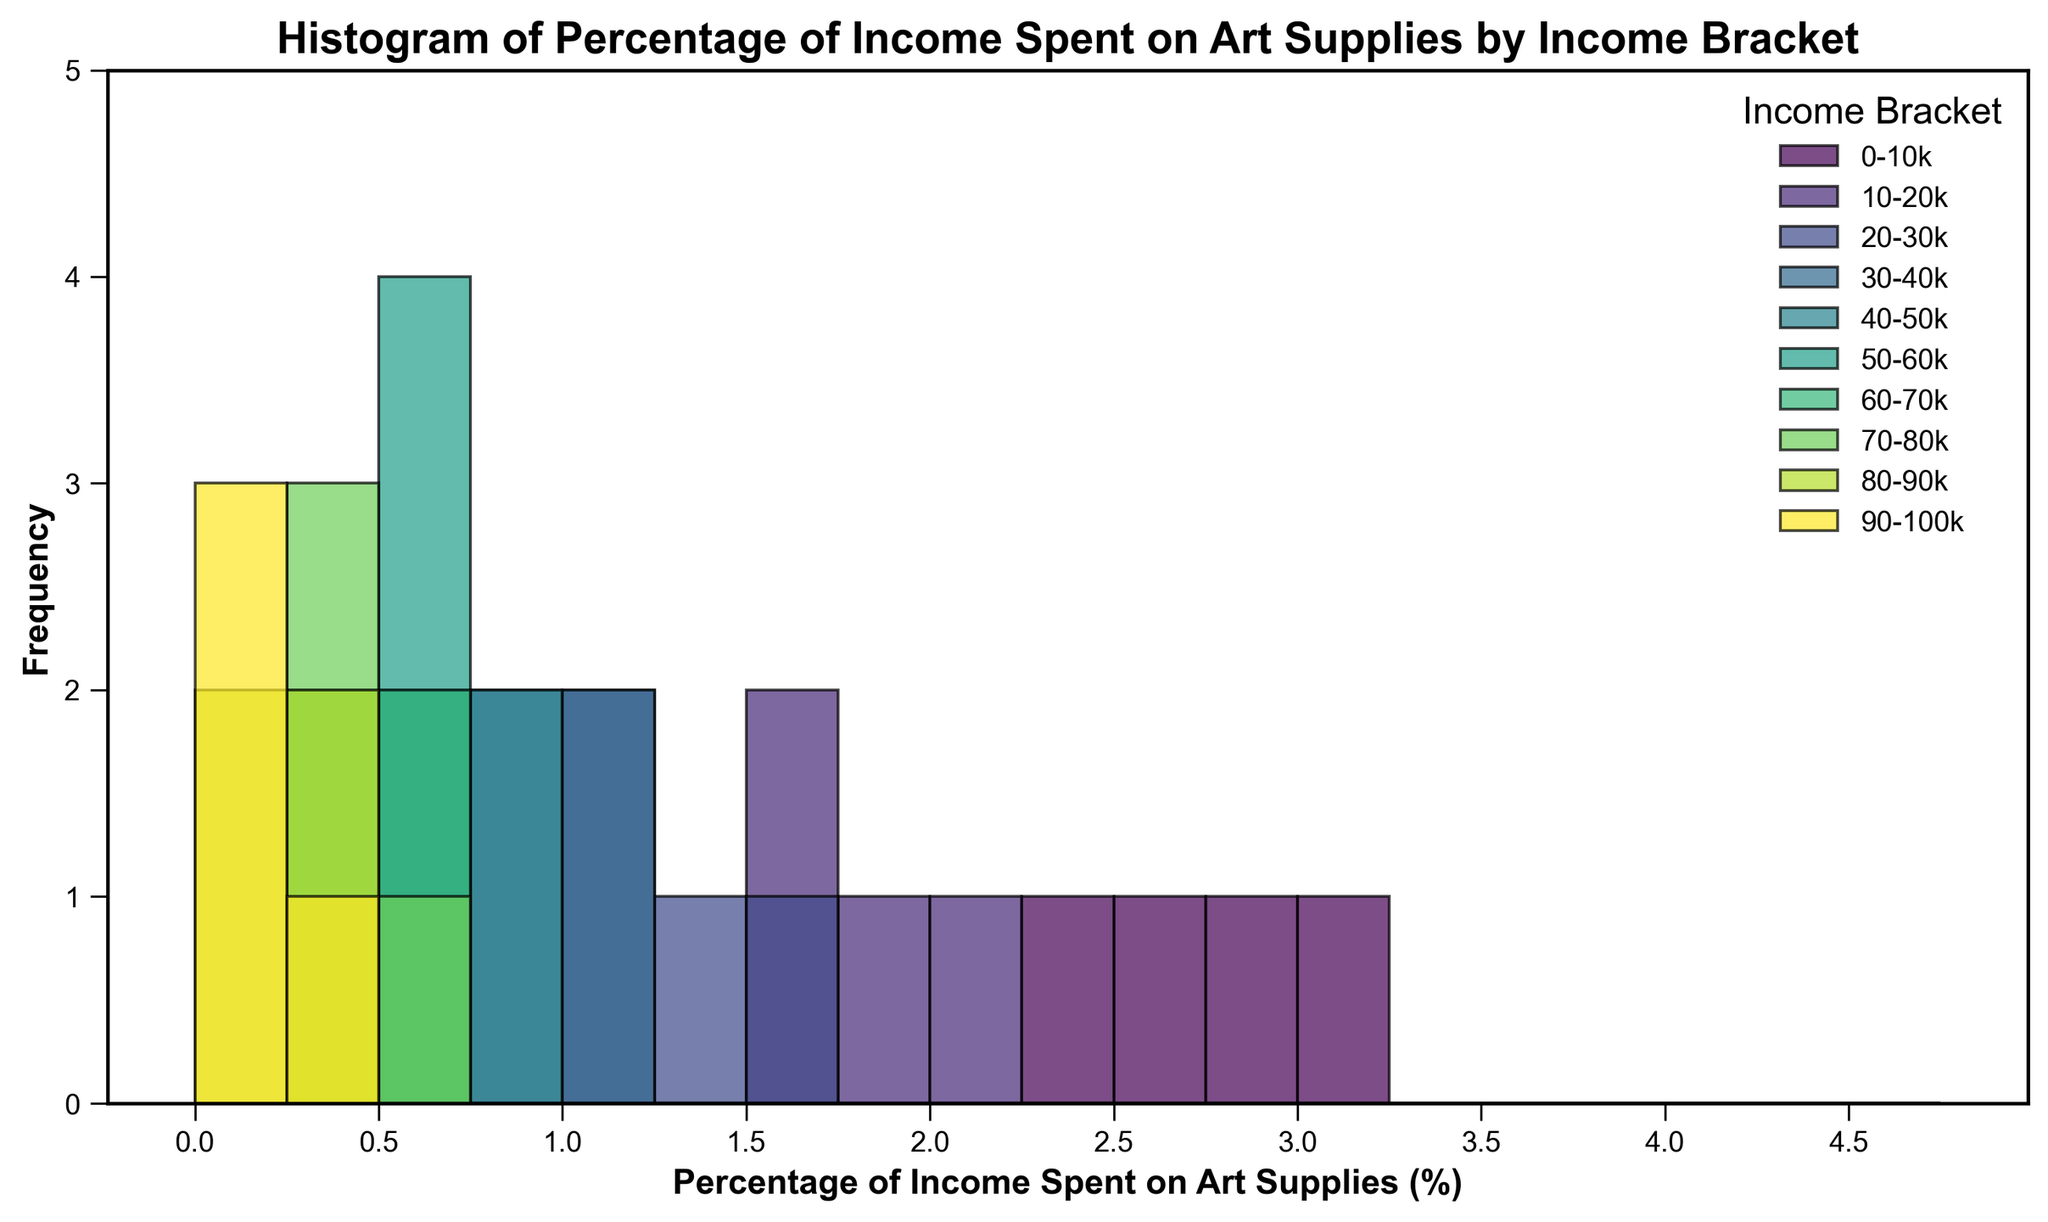Which income bracket has the highest percentage of income spent on art supplies? By looking at the tallest bars in the histogram, we can determine the 0-10k income bracket spends the highest percentage on art supplies.
Answer: 0-10k Which income bracket has the lowest percentage of income spent on art supplies? The shortest bars on the histogram indicate the amount spent; 90-100k has the lowest percentages.
Answer: 90-100k Is the percentage of income spent on art supplies higher for lower income brackets compared to higher income brackets? By examining the histogram, we can see that the lower income brackets have higher bars at higher percentages, showing they spend a larger portion of their income on art supplies.
Answer: Yes What is the most common percentage range of income spent on art supplies for the 10-20k income bracket? The most frequent bar height for the 10-20k group is between 1.5% and 2.0%.
Answer: 1.5% - 2.0% How does the frequency of spending compare between the 30-40k and 50-60k income brackets? Comparing the histograms for these two groups shows that the 30-40k bracket has taller bars compared to the 50-60k income bracket for percentages above 0.5%, suggesting higher frequency.
Answer: 30-40k bracket spends more frequently Do any income brackets have overlapping spending percentages? By visually inspecting the histogram, we can see overlapping spending percentages between different brackets, especially in the ranges of 0.5% to 0.9%.
Answer: Yes What is the range of percentages spent on art supplies for the 20-30k income bracket? The histogram shows bars from 1.1% to 1.5% for the 20-30k income bracket.
Answer: 1.1% - 1.5% How does the spending trend shift as income increases from 0-10k to 30-40k? The histogram shows a decreasing trend in the percentage of income spent on art supplies as income increases from 0-10k to 30-40k.
Answer: Decreasing Is there any income bracket with a bimodal distribution of percentage spent? By examining the histograms for each bracket, none shows two distinct peaks, indicating there is no bimodal distribution.
Answer: No 